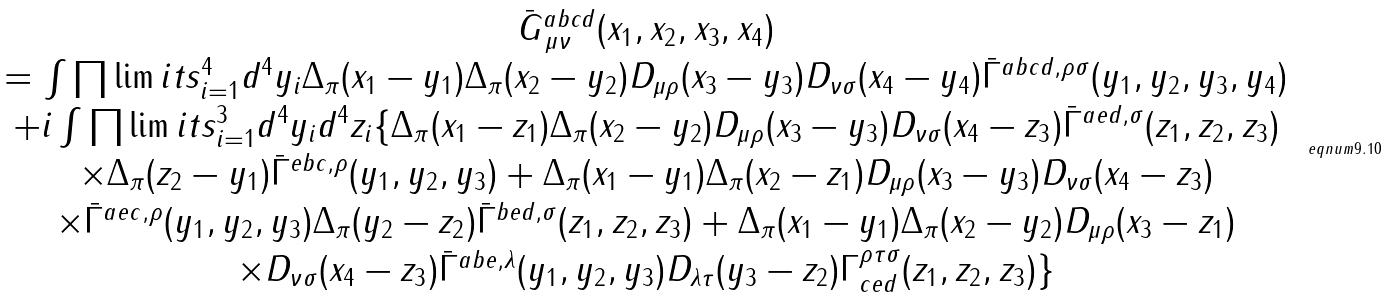Convert formula to latex. <formula><loc_0><loc_0><loc_500><loc_500>\begin{array} { c } \bar { G } _ { \, \mu \nu } ^ { a b c d } ( x _ { 1 } , x _ { 2 } , x _ { 3 } , x _ { 4 } ) \\ = \int \prod \lim i t s _ { i = 1 } ^ { 4 } d ^ { 4 } y _ { i } \Delta _ { \pi } ( x _ { 1 } - y _ { 1 } ) \Delta _ { \pi } ( x _ { 2 } - y _ { 2 } ) D _ { \mu \rho } ( x _ { 3 } - y _ { 3 } ) D _ { \nu \sigma } ( x _ { 4 } - y _ { 4 } ) \bar { \Gamma } ^ { a b c d , \rho \sigma } ( y _ { 1 } , y _ { 2 } , y _ { 3 } , y _ { 4 } ) \\ + i \int \prod \lim i t s _ { i = 1 } ^ { 3 } d ^ { 4 } y _ { i } d ^ { 4 } z _ { i } \{ \Delta _ { \pi } ( x _ { 1 } - z _ { 1 } ) \Delta _ { \pi } ( x _ { 2 } - y _ { 2 } ) D _ { \mu \rho } ( x _ { 3 } - y _ { 3 } ) D _ { \nu \sigma } ( x _ { 4 } - z _ { 3 } ) \bar { \Gamma } ^ { a e d , \sigma } ( z _ { 1 } , z _ { 2 } , z _ { 3 } ) \\ \times \Delta _ { \pi } ( z _ { 2 } - y _ { 1 } ) \bar { \Gamma } ^ { e b c , \rho } ( y _ { 1 } , y _ { 2 } , y _ { 3 } ) + \Delta _ { \pi } ( x _ { 1 } - y _ { 1 } ) \Delta _ { \pi } ( x _ { 2 } - z _ { 1 } ) D _ { \mu \rho } ( x _ { 3 } - y _ { 3 } ) D _ { \nu \sigma } ( x _ { 4 } - z _ { 3 } ) \\ \times \bar { \Gamma } ^ { a e c , \rho } ( y _ { 1 } , y _ { 2 } , y _ { 3 } ) \Delta _ { \pi } ( y _ { 2 } - z _ { 2 } ) \bar { \Gamma } ^ { b e d , \sigma } ( z _ { 1 } , z _ { 2 } , z _ { 3 } ) + \Delta _ { \pi } ( x _ { 1 } - y _ { 1 } ) \Delta _ { \pi } ( x _ { 2 } - y _ { 2 } ) D _ { \mu \rho } ( x _ { 3 } - z _ { 1 } ) \\ \times D _ { \nu \sigma } ( x _ { 4 } - z _ { 3 } ) \bar { \Gamma } ^ { a b e , \lambda } ( y _ { 1 } , y _ { 2 } , y _ { 3 } ) D _ { \lambda \tau } ( y _ { 3 } - z _ { 2 } ) \Gamma _ { c e d } ^ { \rho \tau \sigma } ( z _ { 1 } , z _ { 2 } , z _ { 3 } ) \} \end{array} \ e q n u m { 9 . 1 0 }</formula> 